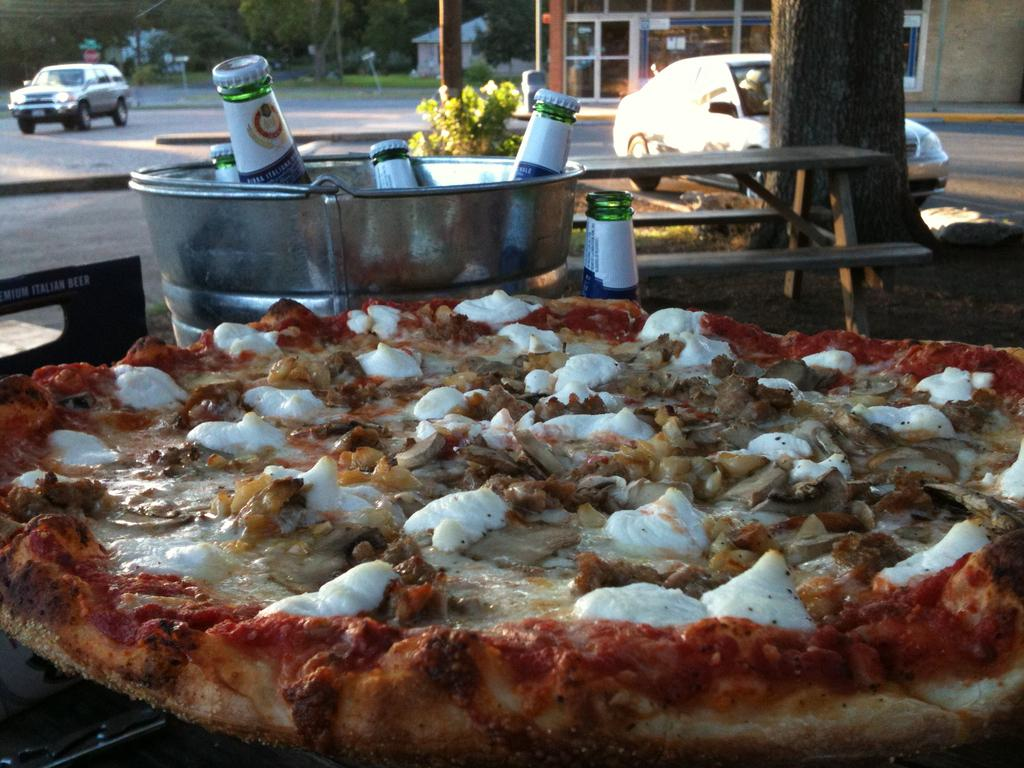What type of food is visible in the image? There is a pizza in the image. What are the bottles placed in? The bottles are in a bucket in the image. What mode of transportation can be seen in the image? There is a car in the image. What type of structure is present in the image? There is a building in the image. What type of plant is visible in the image? There is a tree in the image. What year is depicted in the image? The provided facts do not mention any specific year, so it cannot be determined from the image. Where is the harbor located in the image? There is no harbor present in the image. 